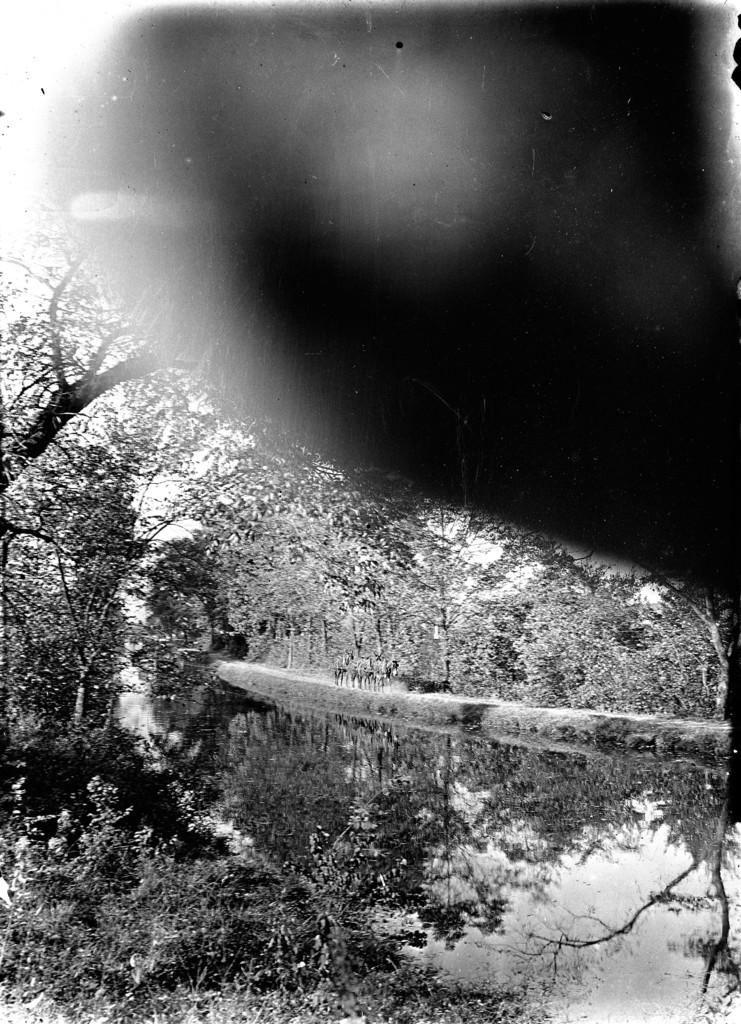What type of natural elements can be seen in the image? There are trees in the image. Can you describe the black object in the top right side of the image? The black object in the top right side of the image is not clearly identifiable, but it is present. What color scheme is used in the image? The image is black and white. Can you tell me how many parts of the stream are visible in the image? There is no stream present in the image; it only features trees and a black object in the top right side. What type of writing can be seen on the trees in the image? There is no writing visible on the trees in the image; it is a black and white image of trees and a black object in the top right side. 